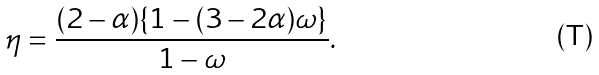<formula> <loc_0><loc_0><loc_500><loc_500>\eta = \frac { ( 2 - \alpha ) \{ 1 - ( 3 - 2 \alpha ) \omega \} } { 1 - \omega } .</formula> 